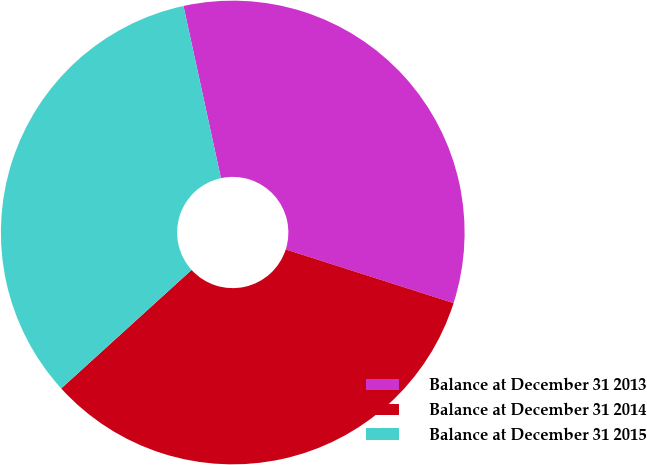<chart> <loc_0><loc_0><loc_500><loc_500><pie_chart><fcel>Balance at December 31 2013<fcel>Balance at December 31 2014<fcel>Balance at December 31 2015<nl><fcel>33.33%<fcel>33.33%<fcel>33.33%<nl></chart> 